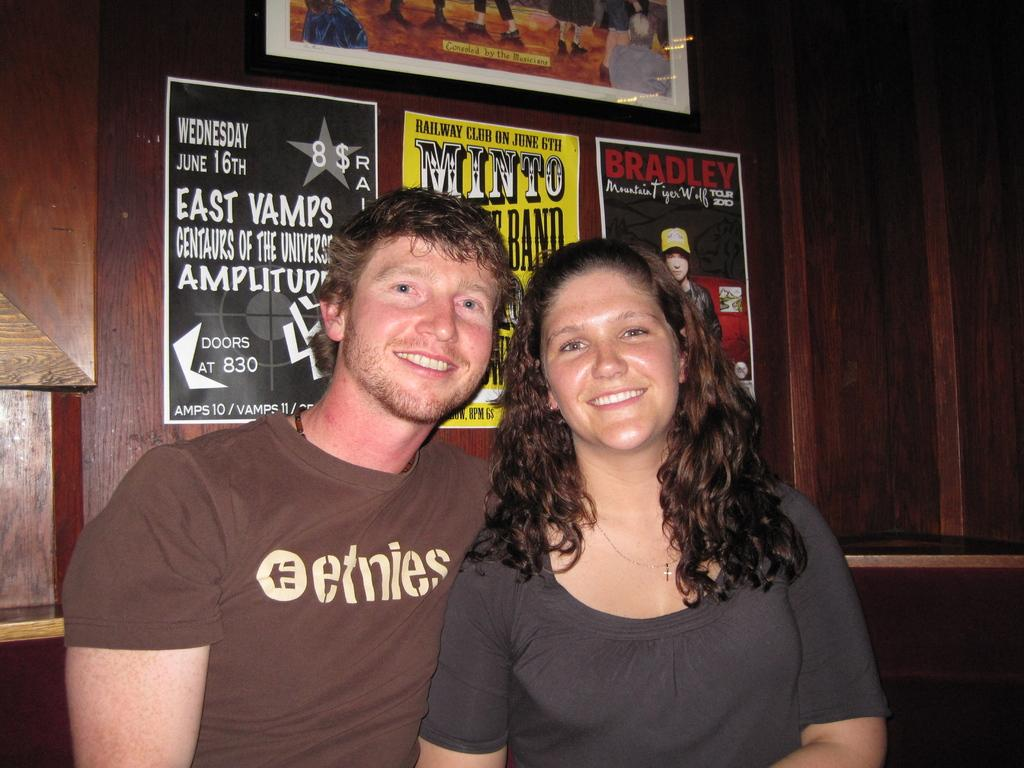Who can be seen in the image? There is a man and a lady in the image. What are the expressions on their faces? Both the man and the lady are smiling. What can be seen in the background of the image? There are posters and a frame on the wall in the background of the image. What flavor of beast can be seen in the image? There is no beast present in the image, and therefore no flavor can be associated with it. 